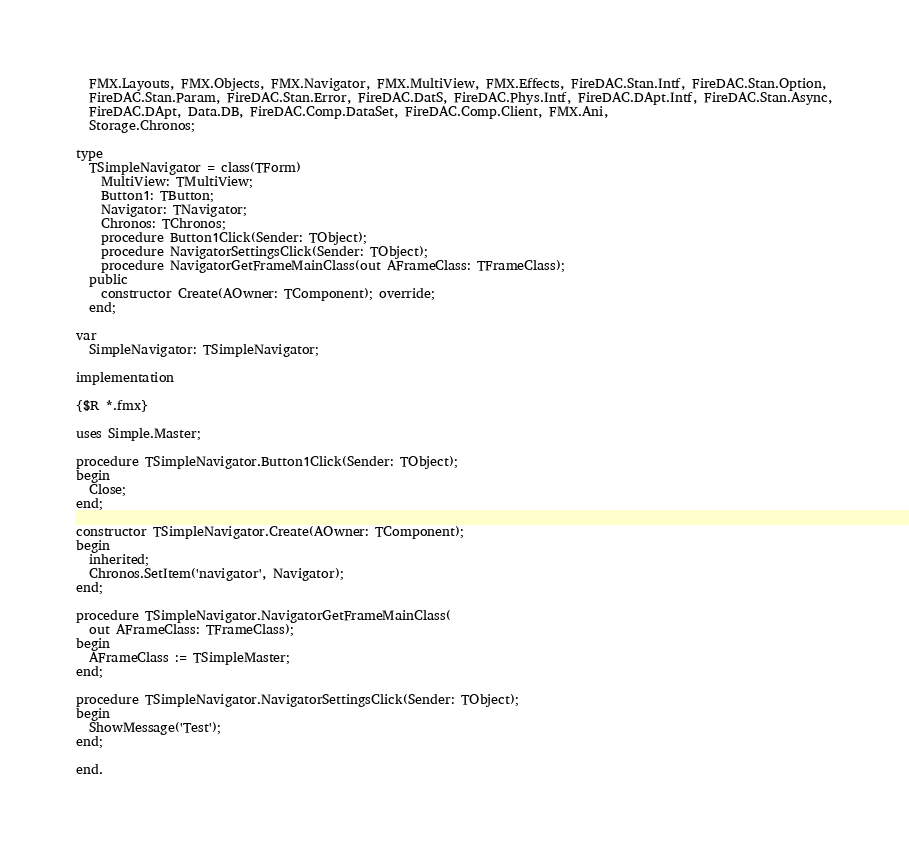<code> <loc_0><loc_0><loc_500><loc_500><_Pascal_>  FMX.Layouts, FMX.Objects, FMX.Navigator, FMX.MultiView, FMX.Effects, FireDAC.Stan.Intf, FireDAC.Stan.Option,
  FireDAC.Stan.Param, FireDAC.Stan.Error, FireDAC.DatS, FireDAC.Phys.Intf, FireDAC.DApt.Intf, FireDAC.Stan.Async,
  FireDAC.DApt, Data.DB, FireDAC.Comp.DataSet, FireDAC.Comp.Client, FMX.Ani,
  Storage.Chronos;

type
  TSimpleNavigator = class(TForm)
    MultiView: TMultiView;
    Button1: TButton;
    Navigator: TNavigator;
    Chronos: TChronos;
    procedure Button1Click(Sender: TObject);
    procedure NavigatorSettingsClick(Sender: TObject);
    procedure NavigatorGetFrameMainClass(out AFrameClass: TFrameClass);
  public
    constructor Create(AOwner: TComponent); override;
  end;

var
  SimpleNavigator: TSimpleNavigator;

implementation

{$R *.fmx}

uses Simple.Master;

procedure TSimpleNavigator.Button1Click(Sender: TObject);
begin
  Close;
end;

constructor TSimpleNavigator.Create(AOwner: TComponent);
begin
  inherited;
  Chronos.SetItem('navigator', Navigator);
end;

procedure TSimpleNavigator.NavigatorGetFrameMainClass(
  out AFrameClass: TFrameClass);
begin
  AFrameClass := TSimpleMaster;
end;

procedure TSimpleNavigator.NavigatorSettingsClick(Sender: TObject);
begin
  ShowMessage('Test');
end;

end.
</code> 